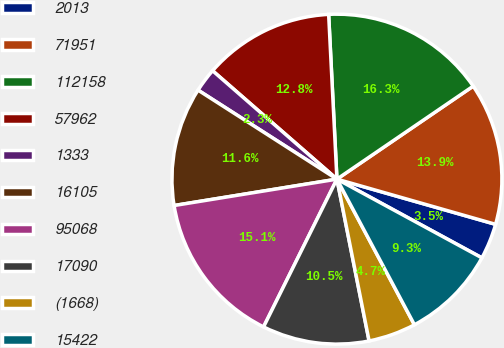Convert chart to OTSL. <chart><loc_0><loc_0><loc_500><loc_500><pie_chart><fcel>2013<fcel>71951<fcel>112158<fcel>57962<fcel>1333<fcel>16105<fcel>95068<fcel>17090<fcel>(1668)<fcel>15422<nl><fcel>3.5%<fcel>13.95%<fcel>16.27%<fcel>12.79%<fcel>2.34%<fcel>11.63%<fcel>15.11%<fcel>10.46%<fcel>4.66%<fcel>9.3%<nl></chart> 